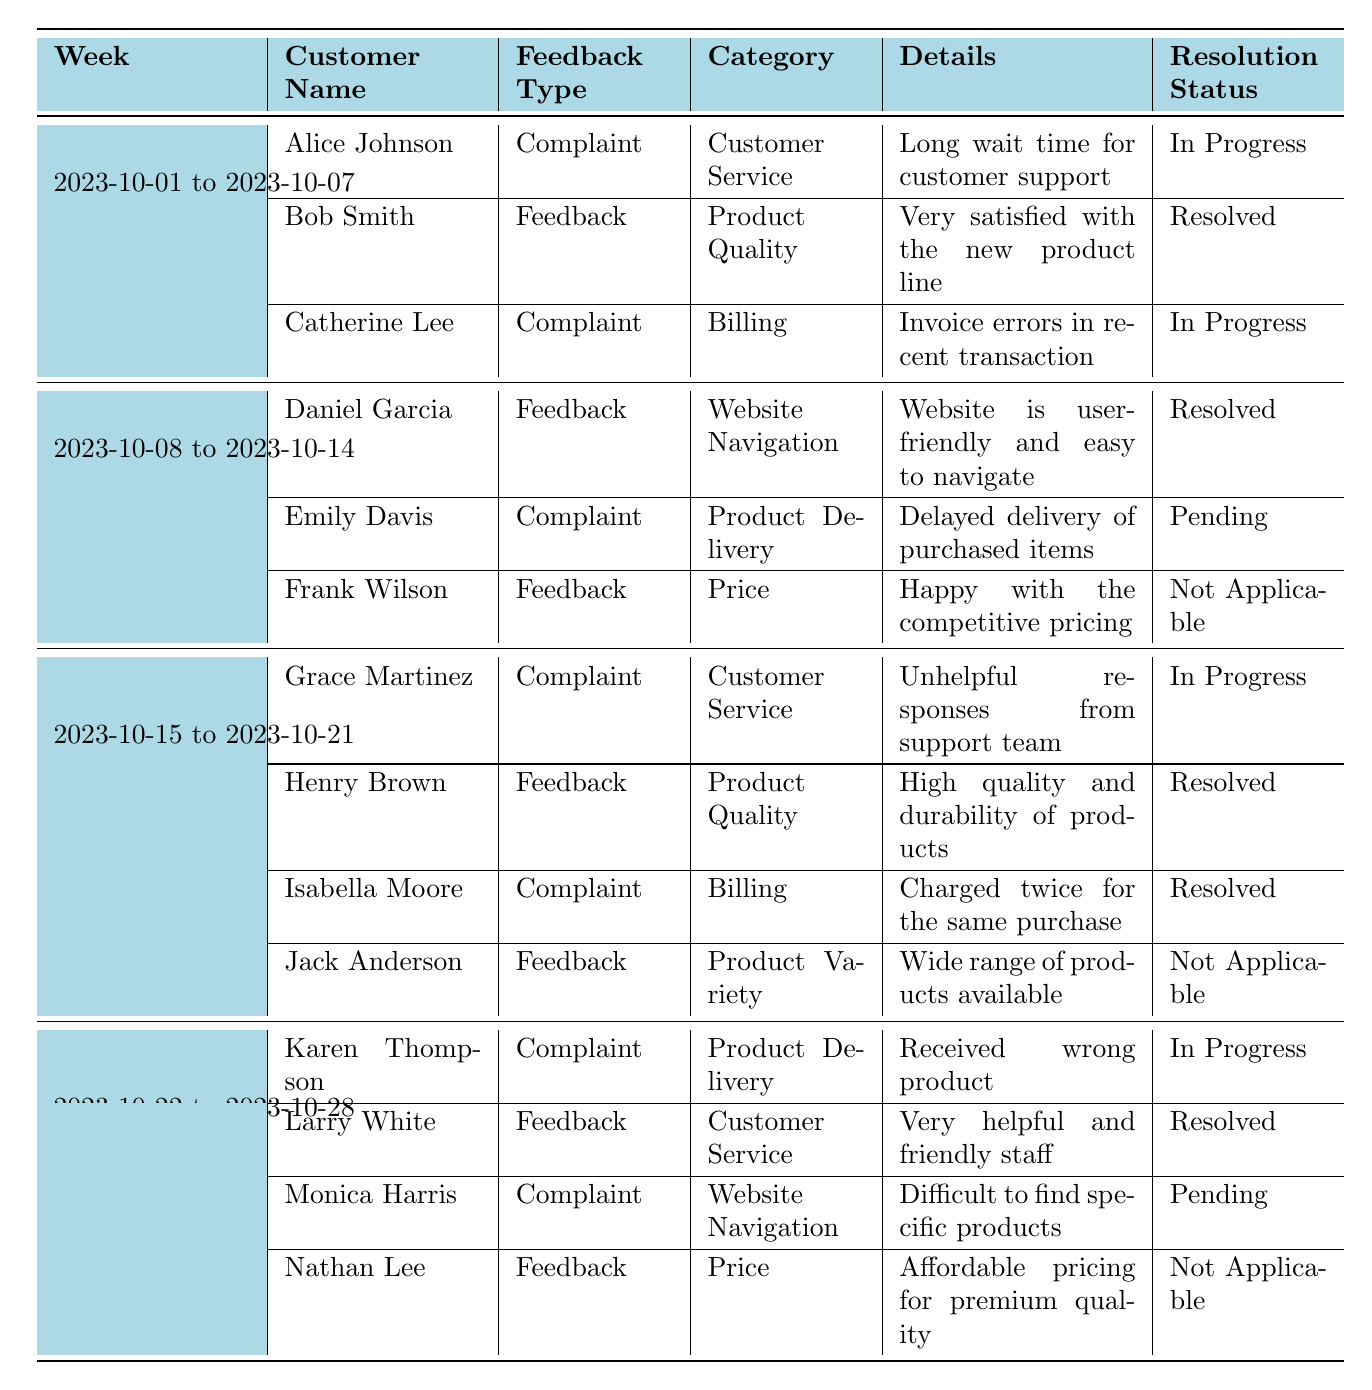What types of feedback did Alice Johnson provide? In the table, Alice Johnson is listed in the week from 2023-10-01 to 2023-10-07 with a feedback type of "Complaint" under the category "Customer Service."
Answer: Complaint How many complaints were unresolved as of the last entry? The table has three complaints listed with the status "In Progress" or "Pending": Alice Johnson, Catherine Lee, and Emily Davis. Thus, there are three unresolved complaints.
Answer: Three Which week had the highest number of feedback entries? Upon examining the weeks, each week contains three or four entries, but 2023-10-15 to 2023-10-21 has four entries, which is the highest among the weeks.
Answer: 2023-10-15 to 2023-10-21 What percentage of feedback entries from 2023-10-01 to 2023-10-07 were complaints? There are three entries in this week, two are complaints (Alice Johnson and Catherine Lee). The percentage is calculated as (2 complaints / 3 total entries) * 100 = 66.67%.
Answer: 66.67% Are there any customers who had their complaints resolved? Yes, both Isabella Moore and Bob Smith had their complaints resolved, as indicated by their resolution status noted in the table.
Answer: Yes How many different categories of feedback were recorded in total? By checking the "Category" column in all rows, the total number of distinct categories listed is 5, which are Customer Service, Product Quality, Billing, Product Delivery, and Website Navigation.
Answer: 5 What is the average resolution status of feedback entries across all weeks? The resolution statuses can be categorized as 5 Resolved, 3 In Progress, 2 Pending, and 4 Not Applicable. The average resolution does not apply as these are statuses rather than numerical values, but the majority are Resolved.
Answer: Majority are Resolved Which customer had feedback regarding the website navigation and what was the resolution status? Emily Davis provided feedback on "Website Navigation" and her complaint regarding delayed delivery was noted as pending.
Answer: Emily Davis, Pending What was the feedback of Nathan Lee and was it resolved? Nathan Lee provided feedback regarding "Price," noting affordable pricing for premium quality and his status is marked as Not Applicable, meaning there is no resolution expected.
Answer: Not Applicable 